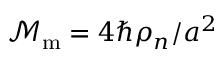<formula> <loc_0><loc_0><loc_500><loc_500>\mathcal { M } _ { m } = { { 4 \hbar { \rho } _ { n } } / { a ^ { 2 } } }</formula> 